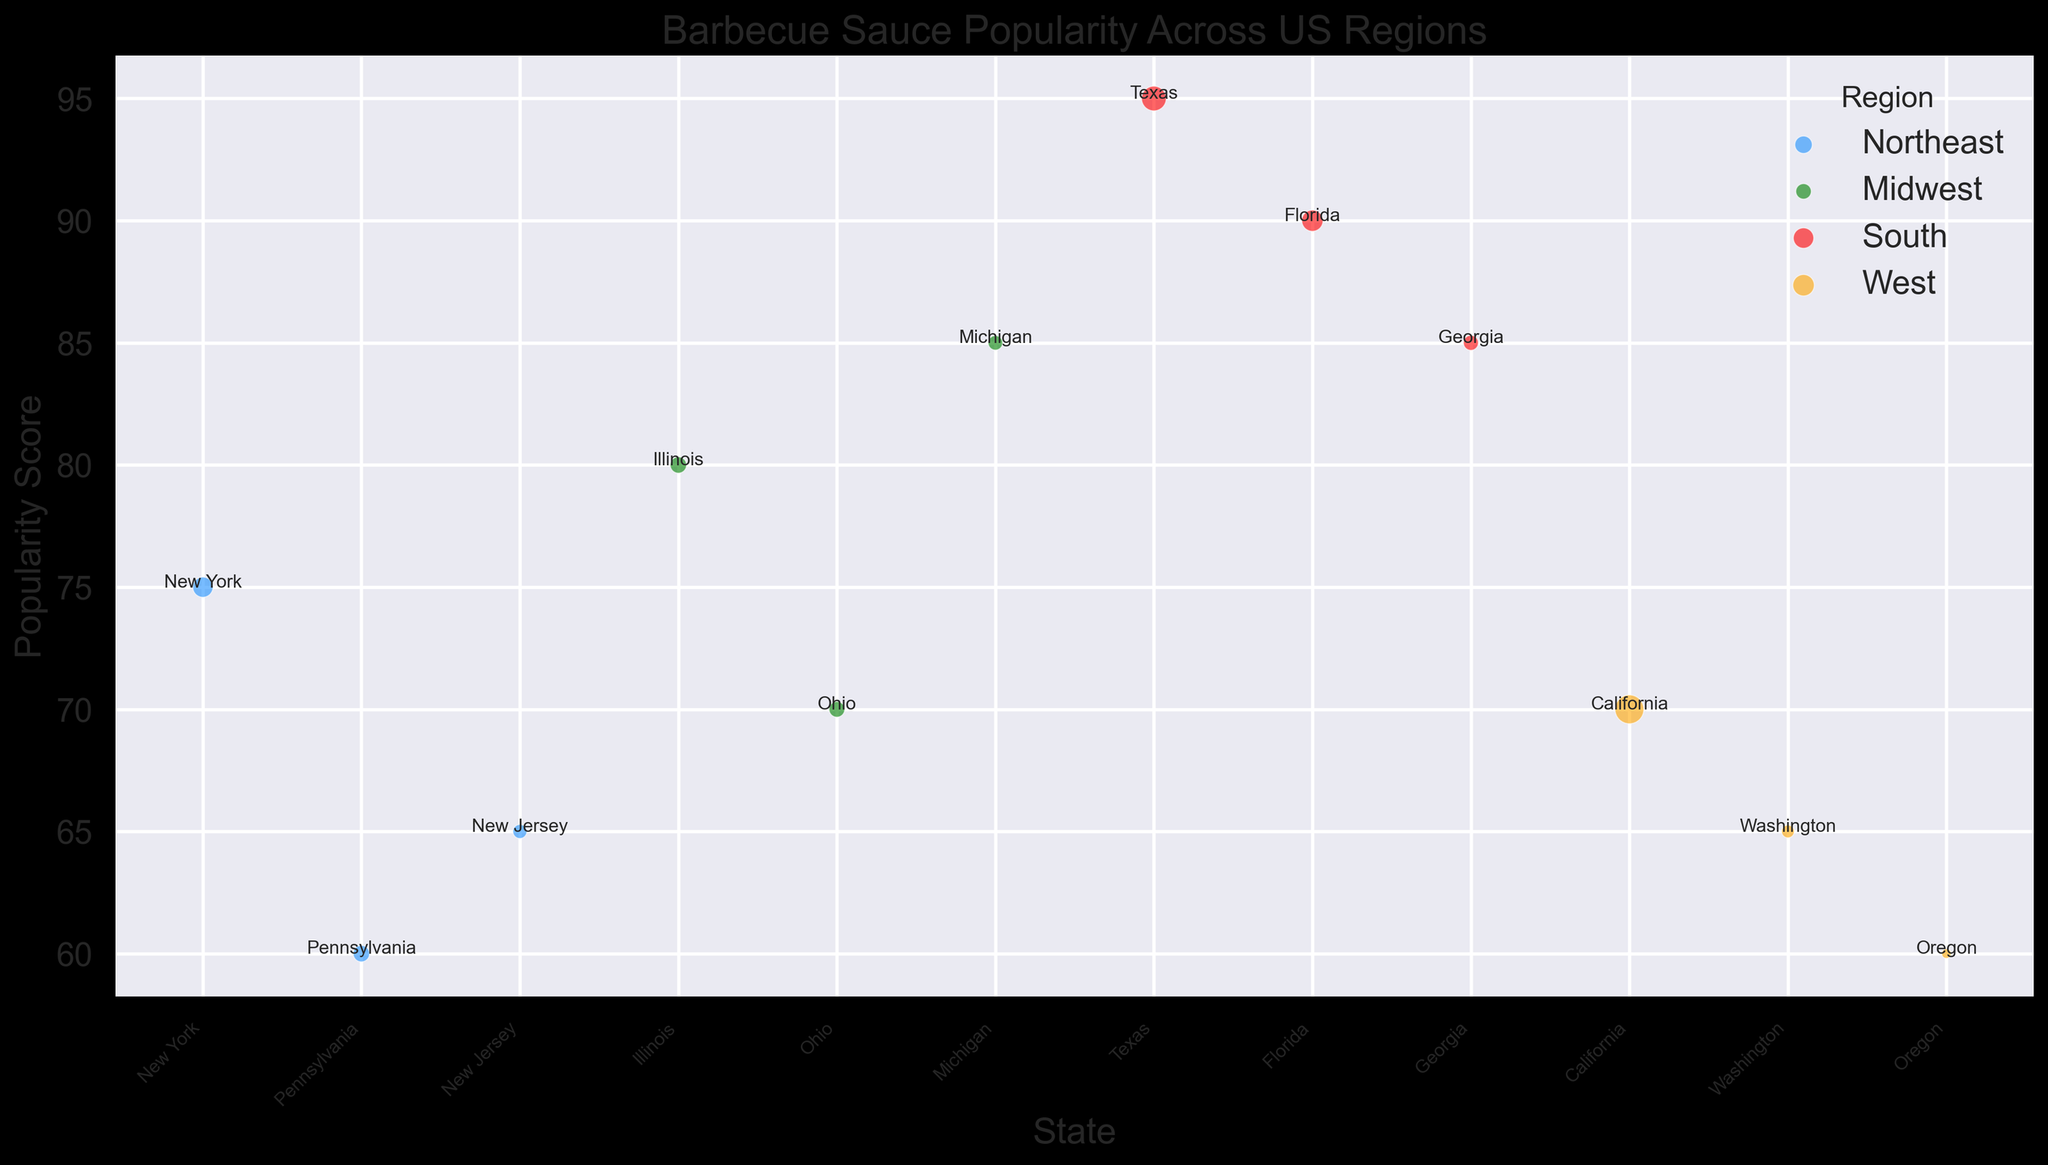Which region has the highest barbecue sauce popularity score? The red color represents the South, which has Texas with a score of 95. This is the highest score on the chart.
Answer: South Which state in the Northeast has the highest barbecue sauce popularity score? In the Northeast region, New York has the highest score of 75. This can be seen by looking at the blue dots representing the Northeast.
Answer: New York Is the popularity score of barbecue sauce in California greater than in Washington? California is represented by an orange dot with a score of 70, while Washington, also represented by an orange dot, has a score of 65.
Answer: Yes Which two regions have states with scores of 85? The green color represents Michigan in the Midwest with an 85 score, and the red color represents Georgia in the South with an 85 score.
Answer: Midwest and South What is the combined population of states with a popularity score higher than 80? The states with scores higher than 80 are Illinois (80, Population: 12671821), Michigan (85, Population: 9986857), Texas (95, Population: 28995881), Florida (90, Population: 21477737), and Georgia (85, Population: 10617423). Adding these: 12671821 + 9986857 + 28995881 + 21477737 + 10617423 = 83749719.
Answer: 83749719 Which region has the largest state population, and what is the popularity score of that state? The state with the largest population is California in the West with a population of 39512223 and a popularity score of 70, represented by an orange dot.
Answer: West, 70 Compare the barbecue sauce popularity between Texas and New York. Which state has a higher score, and by how much? Texas in the South has a score of 95, while New York in the Northeast has a score of 75. The difference is 95 - 75 = 20.
Answer: Texas by 20 Which state in the West has the lowest barbecue sauce popularity score? The states in the West are represented by orange dots. Oregon, with a score of 60, has the lowest among them.
Answer: Oregon 